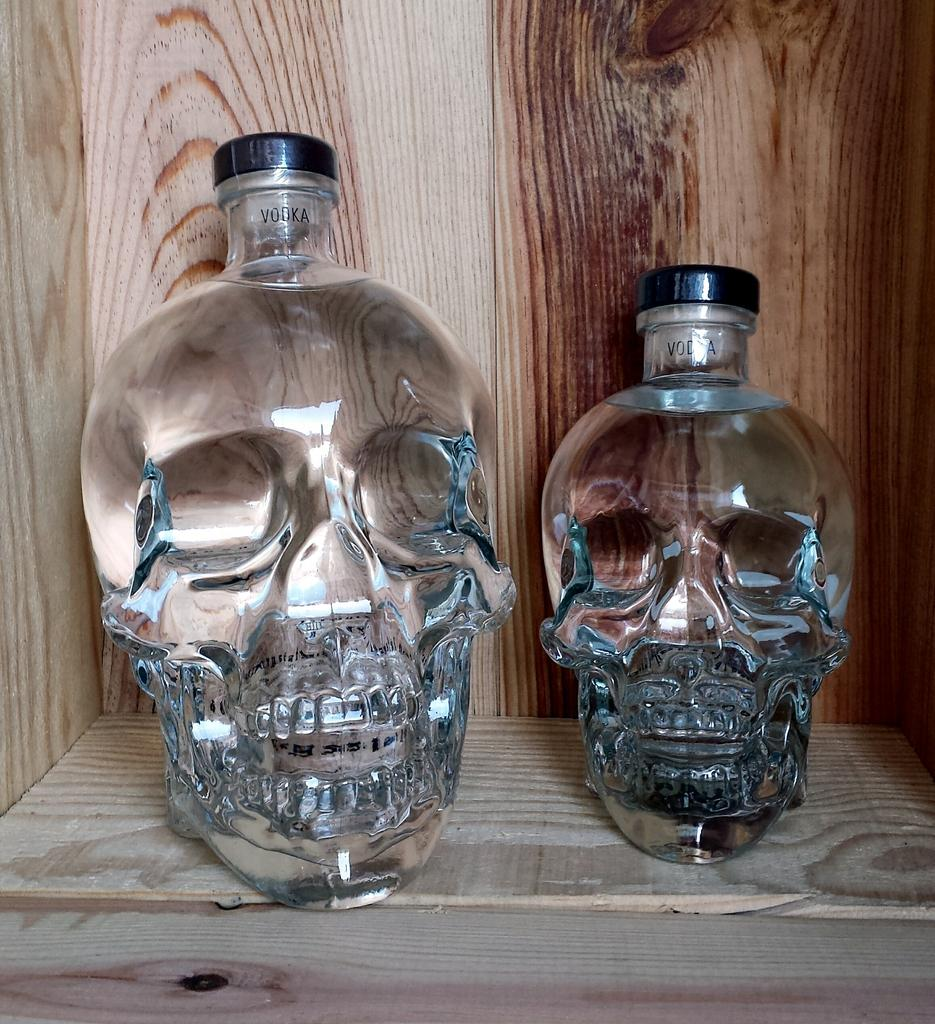What type of bottles are depicted in the image? The bottles in the image are skull-shaped. Can you describe the design of the bottles? The bottles have a skull shape, which is a unique and distinct design. What type of toothpaste is being used with the skull-shaped bottles in the image? There is no toothpaste present in the image; it only features skull-shaped bottles. Is there a baby holding one of the skull-shaped bottles in the image? There is no baby present in the image; it only features skull-shaped bottles. 